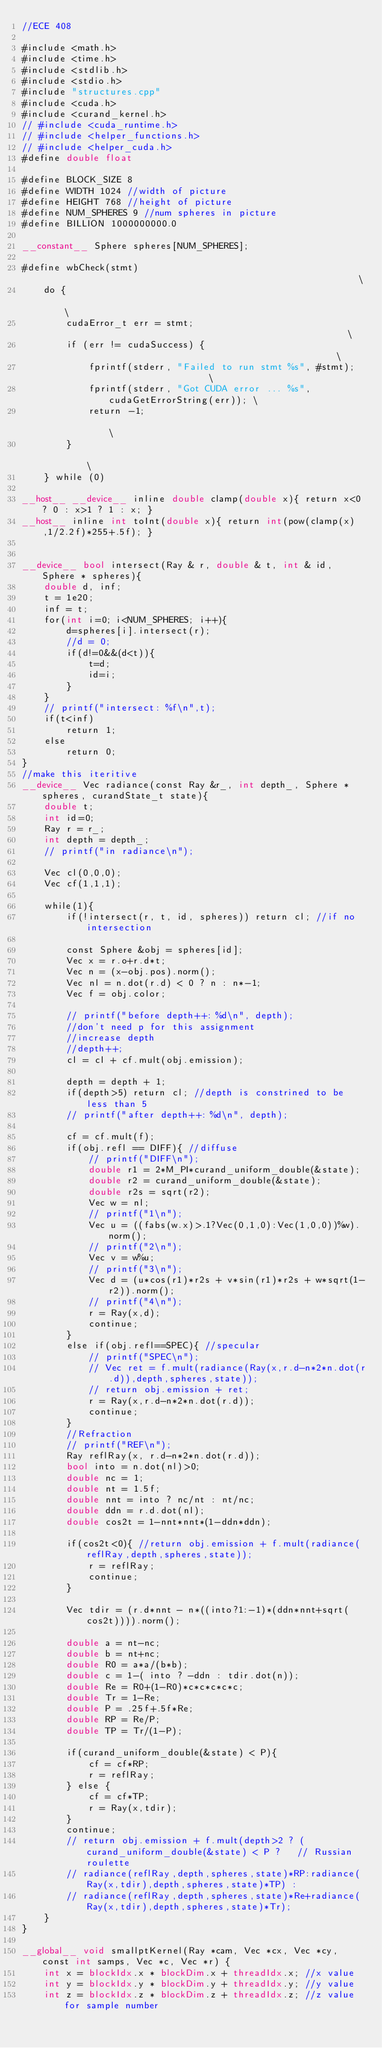Convert code to text. <code><loc_0><loc_0><loc_500><loc_500><_Cuda_>//ECE 408

#include <math.h>
#include <time.h>
#include <stdlib.h>
#include <stdio.h>
#include "structures.cpp"
#include <cuda.h>
#include <curand_kernel.h>
// #include <cuda_runtime.h>
// #include <helper_functions.h>
// #include <helper_cuda.h>
#define double float

#define BLOCK_SIZE 8
#define WIDTH 1024 //width of picture
#define HEIGHT 768 //height of picture
#define NUM_SPHERES 9 //num spheres in picture
#define BILLION 1000000000.0

__constant__ Sphere spheres[NUM_SPHERES];

#define wbCheck(stmt)                                                          \
    do {                                                                       \
        cudaError_t err = stmt;                                                \
        if (err != cudaSuccess) {                                              \
            fprintf(stderr, "Failed to run stmt %s", #stmt);                   \
            fprintf(stderr, "Got CUDA error ... %s", cudaGetErrorString(err)); \
            return -1;                                                         \
        }                                                                      \
    } while (0)

__host__ __device__ inline double clamp(double x){ return x<0 ? 0 : x>1 ? 1 : x; }
__host__ inline int toInt(double x){ return int(pow(clamp(x),1/2.2f)*255+.5f); }


__device__ bool intersect(Ray & r, double & t, int & id, Sphere * spheres){
    double d, inf;
    t = 1e20;
    inf = t;    
    for(int i=0; i<NUM_SPHERES; i++){
        d=spheres[i].intersect(r);
        //d = 0;
        if(d!=0&&(d<t)){
            t=d;
            id=i;
        }
    }
    // printf("intersect: %f\n",t);
    if(t<inf)
        return 1;
    else
        return 0;
}
//make this iteritive
__device__ Vec radiance(const Ray &r_, int depth_, Sphere * spheres, curandState_t state){
    double t;
    int id=0;
    Ray r = r_;
    int depth = depth_;
    // printf("in radiance\n");

    Vec cl(0,0,0);
    Vec cf(1,1,1);

    while(1){
        if(!intersect(r, t, id, spheres)) return cl; //if no intersection

        const Sphere &obj = spheres[id];
        Vec x = r.o+r.d*t;
        Vec n = (x-obj.pos).norm();
        Vec nl = n.dot(r.d) < 0 ? n : n*-1;
        Vec f = obj.color;

        // printf("before depth++: %d\n", depth);
        //don't need p for this assignment
        //increase depth
        //depth++;
        cl = cl + cf.mult(obj.emission);

        depth = depth + 1;
        if(depth>5) return cl; //depth is constrined to be less than 5 
        // printf("after depth++: %d\n", depth);

        cf = cf.mult(f);
        if(obj.refl == DIFF){ //diffuse
            // printf("DIFF\n");
            double r1 = 2*M_PI*curand_uniform_double(&state);
            double r2 = curand_uniform_double(&state);
            double r2s = sqrt(r2);
            Vec w = nl;
            // printf("1\n");
            Vec u = ((fabs(w.x)>.1?Vec(0,1,0):Vec(1,0,0))%w).norm();
            // printf("2\n");
            Vec v = w%u;
            // printf("3\n");
            Vec d = (u*cos(r1)*r2s + v*sin(r1)*r2s + w*sqrt(1-r2)).norm();
            // printf("4\n");
            r = Ray(x,d);
            continue;
        }
        else if(obj.refl==SPEC){ //specular
            // printf("SPEC\n");
            // Vec ret = f.mult(radiance(Ray(x,r.d-n*2*n.dot(r.d)),depth,spheres,state));
            // return obj.emission + ret;
            r = Ray(x,r.d-n*2*n.dot(r.d));
            continue;
        }
        //Refraction
        // printf("REF\n");
        Ray reflRay(x, r.d-n*2*n.dot(r.d));
        bool into = n.dot(nl)>0;  
        double nc = 1;
        double nt = 1.5f;
        double nnt = into ? nc/nt : nt/nc;
        double ddn = r.d.dot(nl);
        double cos2t = 1-nnt*nnt*(1-ddn*ddn);

        if(cos2t<0){ //return obj.emission + f.mult(radiance(reflRay,depth,spheres,state));
            r = reflRay;
            continue;
        }

        Vec tdir = (r.d*nnt - n*((into?1:-1)*(ddn*nnt+sqrt(cos2t)))).norm();

        double a = nt-nc;
        double b = nt+nc;
        double R0 = a*a/(b*b);
        double c = 1-( into ? -ddn : tdir.dot(n));
        double Re = R0+(1-R0)*c*c*c*c*c;
        double Tr = 1-Re;
        double P = .25f+.5f*Re;
        double RP = Re/P;
        double TP = Tr/(1-P);
        
        if(curand_uniform_double(&state) < P){
            cf = cf*RP;
            r = reflRay;
        } else {
            cf = cf*TP;
            r = Ray(x,tdir);
        }
        continue;
        // return obj.emission + f.mult(depth>2 ? (curand_uniform_double(&state) < P ?   // Russian roulette
        // radiance(reflRay,depth,spheres,state)*RP:radiance(Ray(x,tdir),depth,spheres,state)*TP) :
        // radiance(reflRay,depth,spheres,state)*Re+radiance(Ray(x,tdir),depth,spheres,state)*Tr);
    }
}

__global__ void smallptKernel(Ray *cam, Vec *cx, Vec *cy, const int samps, Vec *c, Vec *r) {
    int x = blockIdx.x * blockDim.x + threadIdx.x; //x value
    int y = blockIdx.y * blockDim.y + threadIdx.y; //y value
    int z = blockIdx.z * blockDim.z + threadIdx.z; //z value for sample number
</code> 